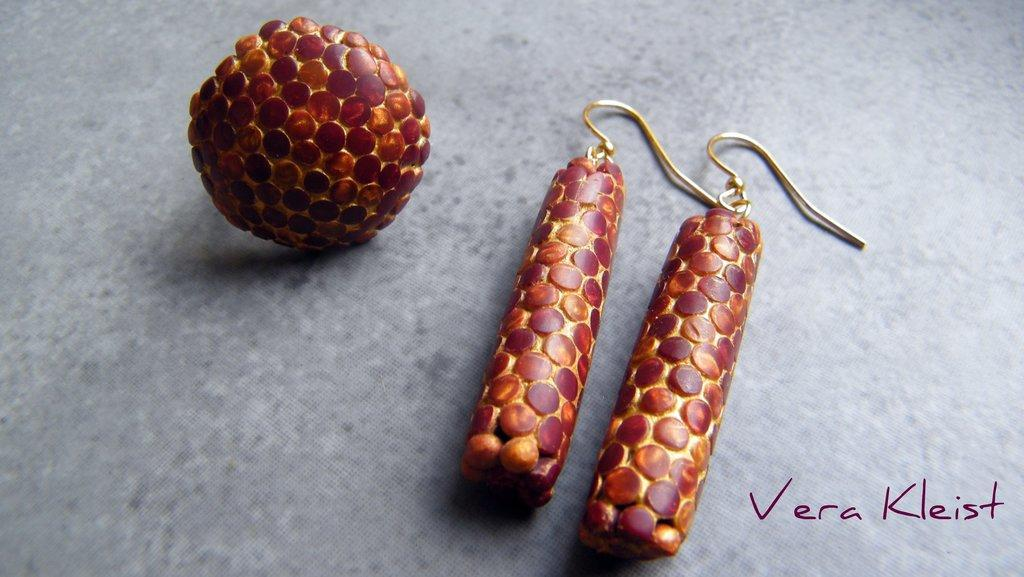What is the main subject of the image? The main subject of the image is a pair of earrings. Where are the earrings located in the image? The earrings are in the center of the image. Is there any text present in the image? Yes, there is text at the bottom side of the image. What type of shock can be seen affecting the earrings in the image? There is no shock present in the image; the earrings are stationary and not affected by any external force. 